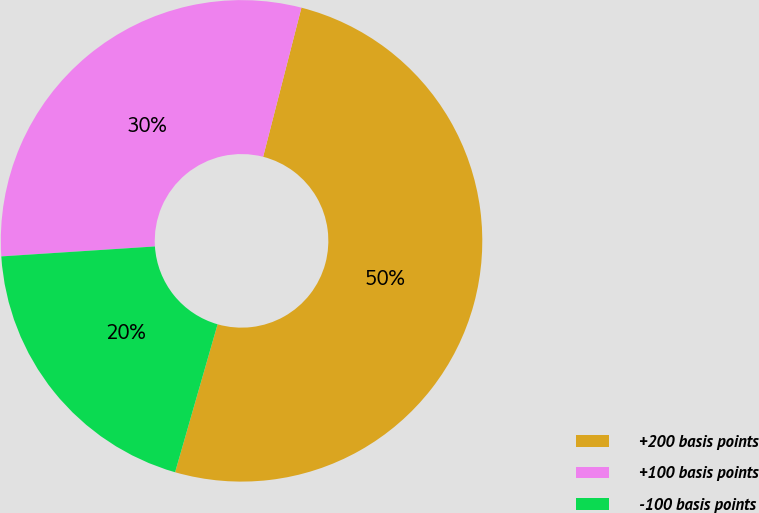<chart> <loc_0><loc_0><loc_500><loc_500><pie_chart><fcel>+200 basis points<fcel>+100 basis points<fcel>-100 basis points<nl><fcel>50.45%<fcel>30.03%<fcel>19.52%<nl></chart> 